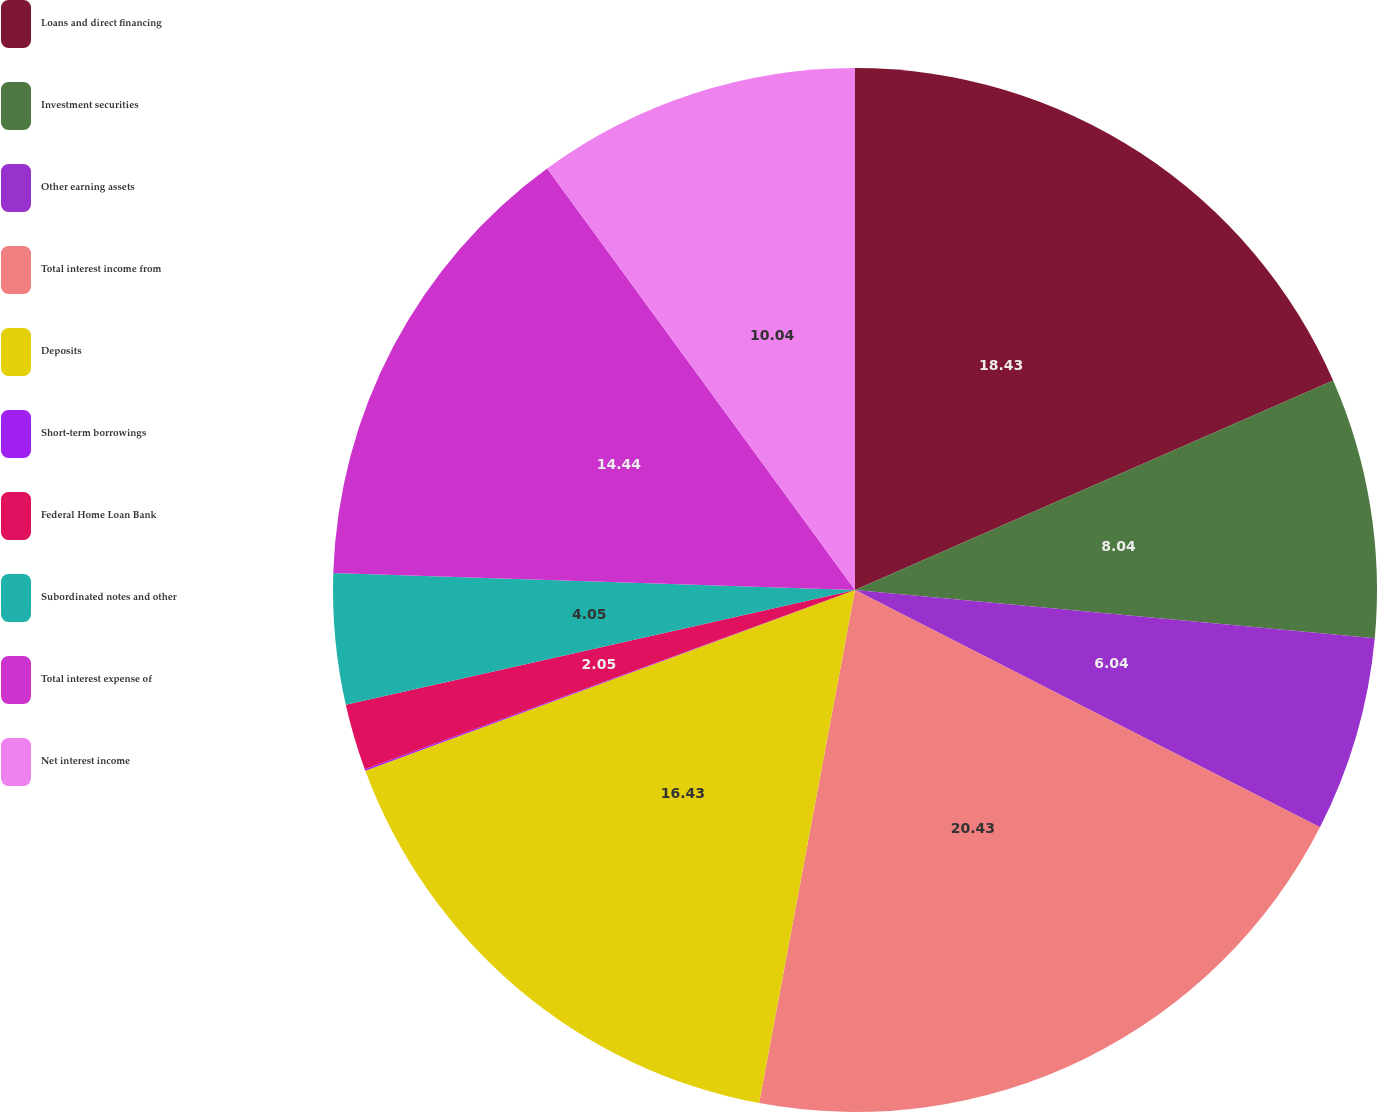Convert chart to OTSL. <chart><loc_0><loc_0><loc_500><loc_500><pie_chart><fcel>Loans and direct financing<fcel>Investment securities<fcel>Other earning assets<fcel>Total interest income from<fcel>Deposits<fcel>Short-term borrowings<fcel>Federal Home Loan Bank<fcel>Subordinated notes and other<fcel>Total interest expense of<fcel>Net interest income<nl><fcel>18.43%<fcel>8.04%<fcel>6.04%<fcel>20.43%<fcel>16.43%<fcel>0.05%<fcel>2.05%<fcel>4.05%<fcel>14.44%<fcel>10.04%<nl></chart> 